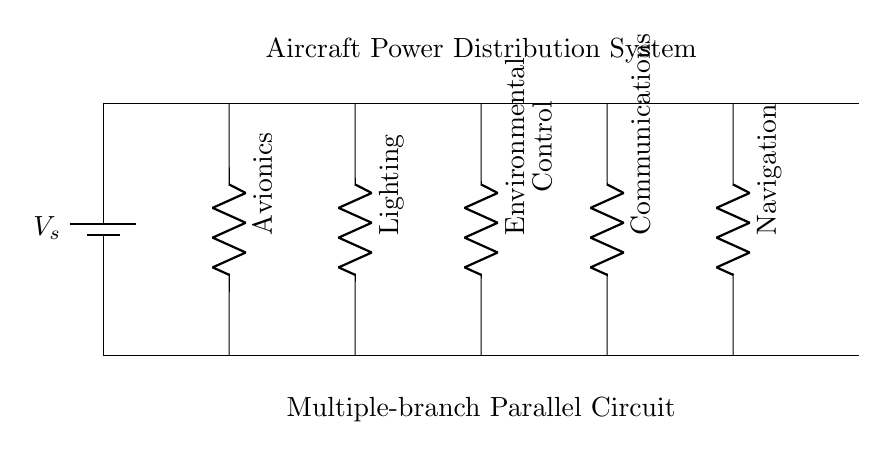What are the components shown in the circuit? The components in the circuit include a power source (battery) and five resistors representing different aircraft subsystems.
Answer: battery, resistors What are the subsystems connected to the circuit? The subsystems connected to the circuit are Avionics, Lighting, Environmental Control, Communications, and Navigation.
Answer: Avionics, Lighting, Environmental Control, Communications, Navigation How many branches are there in this circuit? The circuit has five branches, one for each subsystem. Branches are represented by the resistors that connect from the main distribution line to the ground.
Answer: five What is the purpose of a parallel circuit in this context? A parallel circuit allows for the independent operation of each subsystem, ensuring that failure in one does not affect the others.
Answer: independent operation What happens if one branch fails? If one branch fails, the remaining branches will continue to operate normally, as they are connected in parallel.
Answer: remaining branches operate What could be the total resistance of this circuit? The total resistance of the circuit is calculated using the formula for parallel resistances, but the individual values are not provided in the diagram. Thus, it's not possible to determine total resistance precisely without those values.
Answer: not calculable 